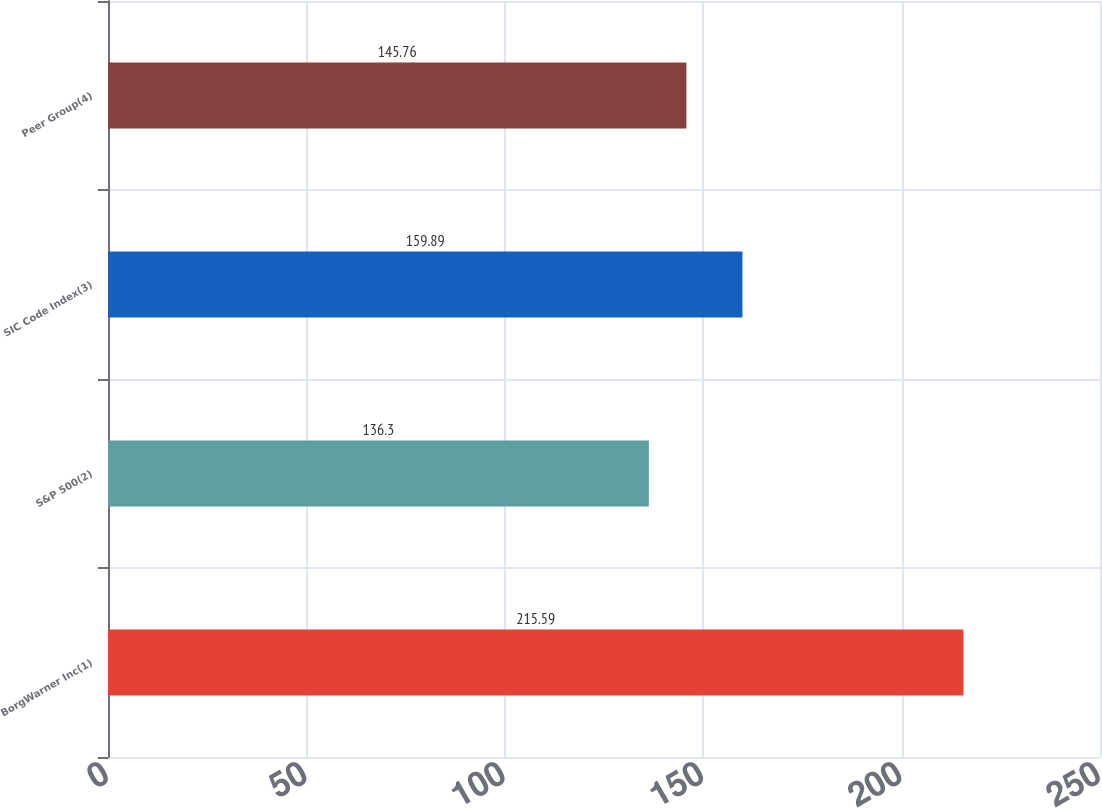Convert chart to OTSL. <chart><loc_0><loc_0><loc_500><loc_500><bar_chart><fcel>BorgWarner Inc(1)<fcel>S&P 500(2)<fcel>SIC Code Index(3)<fcel>Peer Group(4)<nl><fcel>215.59<fcel>136.3<fcel>159.89<fcel>145.76<nl></chart> 